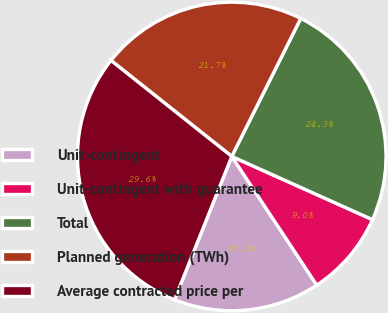Convert chart to OTSL. <chart><loc_0><loc_0><loc_500><loc_500><pie_chart><fcel>Unit-contingent<fcel>Unit-contingent with guarantee<fcel>Total<fcel>Planned generation (TWh)<fcel>Average contracted price per<nl><fcel>15.34%<fcel>8.99%<fcel>24.34%<fcel>21.69%<fcel>29.63%<nl></chart> 